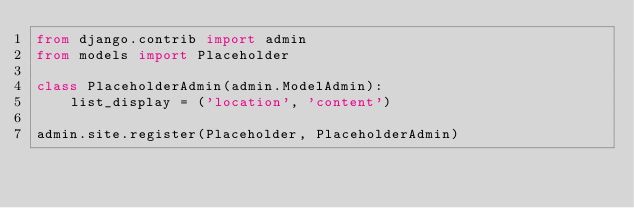Convert code to text. <code><loc_0><loc_0><loc_500><loc_500><_Python_>from django.contrib import admin
from models import Placeholder

class PlaceholderAdmin(admin.ModelAdmin):
	list_display = ('location', 'content')

admin.site.register(Placeholder, PlaceholderAdmin)

</code> 